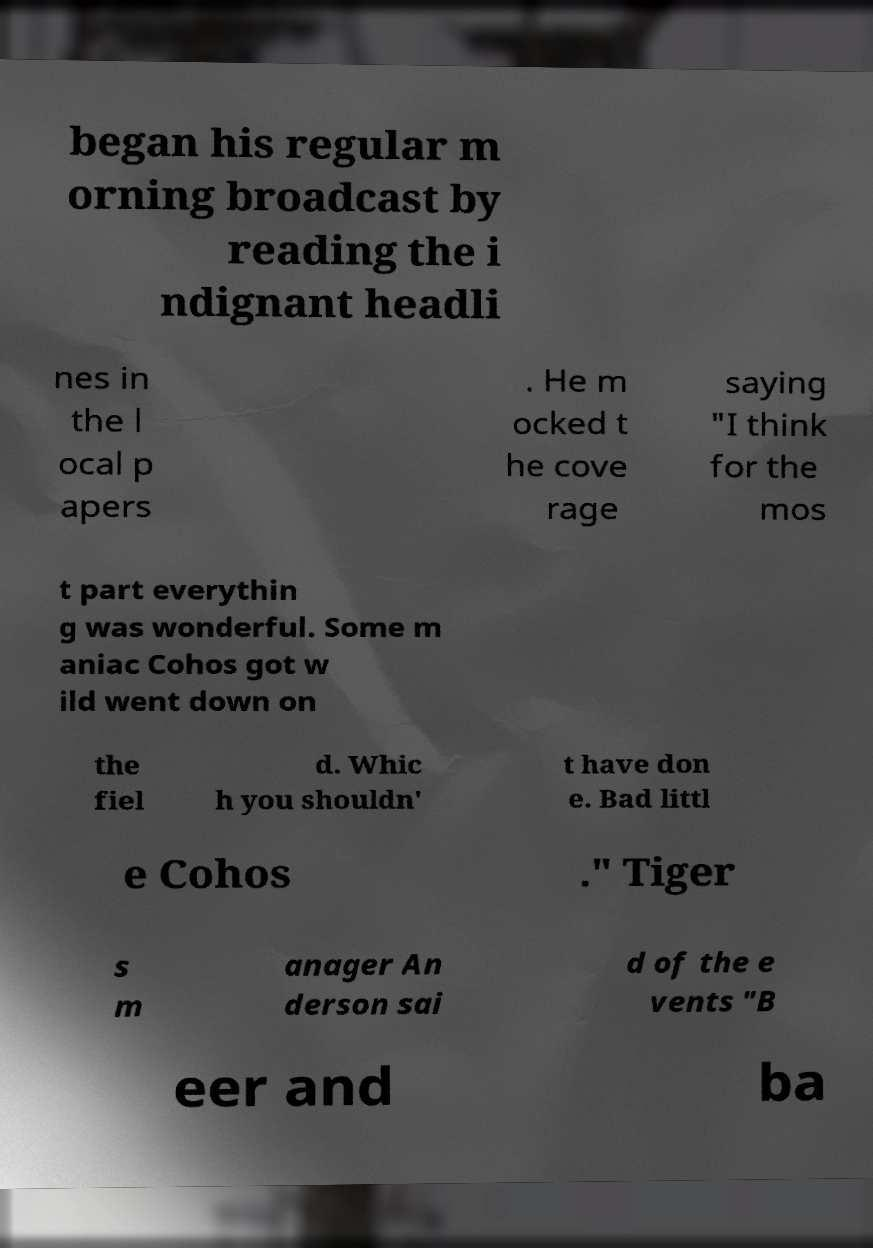Could you assist in decoding the text presented in this image and type it out clearly? began his regular m orning broadcast by reading the i ndignant headli nes in the l ocal p apers . He m ocked t he cove rage saying "I think for the mos t part everythin g was wonderful. Some m aniac Cohos got w ild went down on the fiel d. Whic h you shouldn' t have don e. Bad littl e Cohos ." Tiger s m anager An derson sai d of the e vents "B eer and ba 